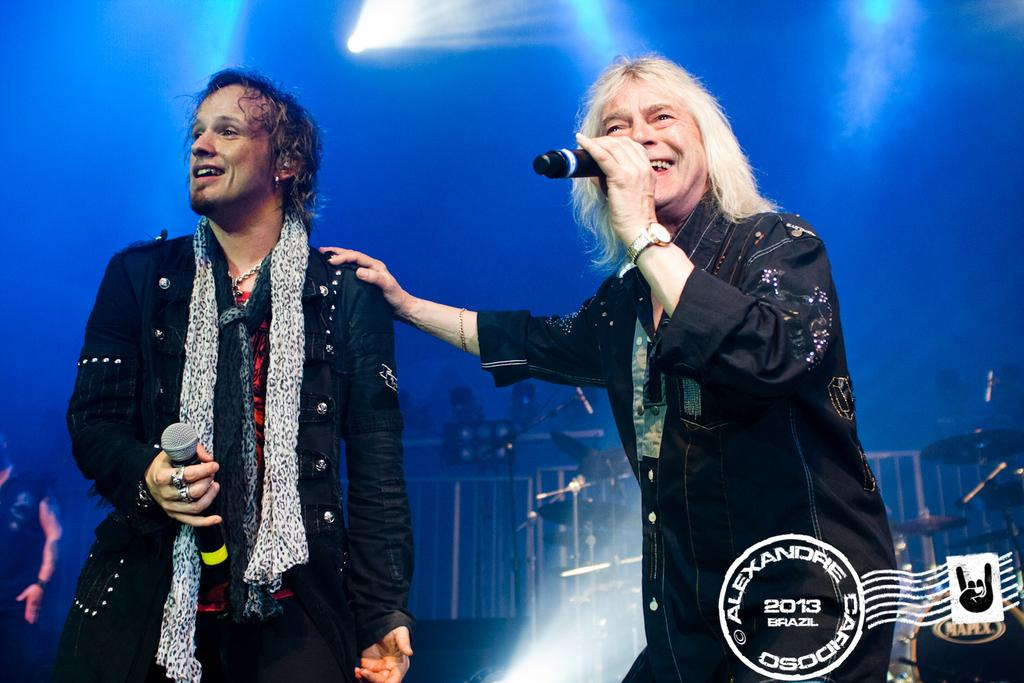<image>
Give a short and clear explanation of the subsequent image. Two men adorn a postcard by Alexandre Cafidoso from 2013. 